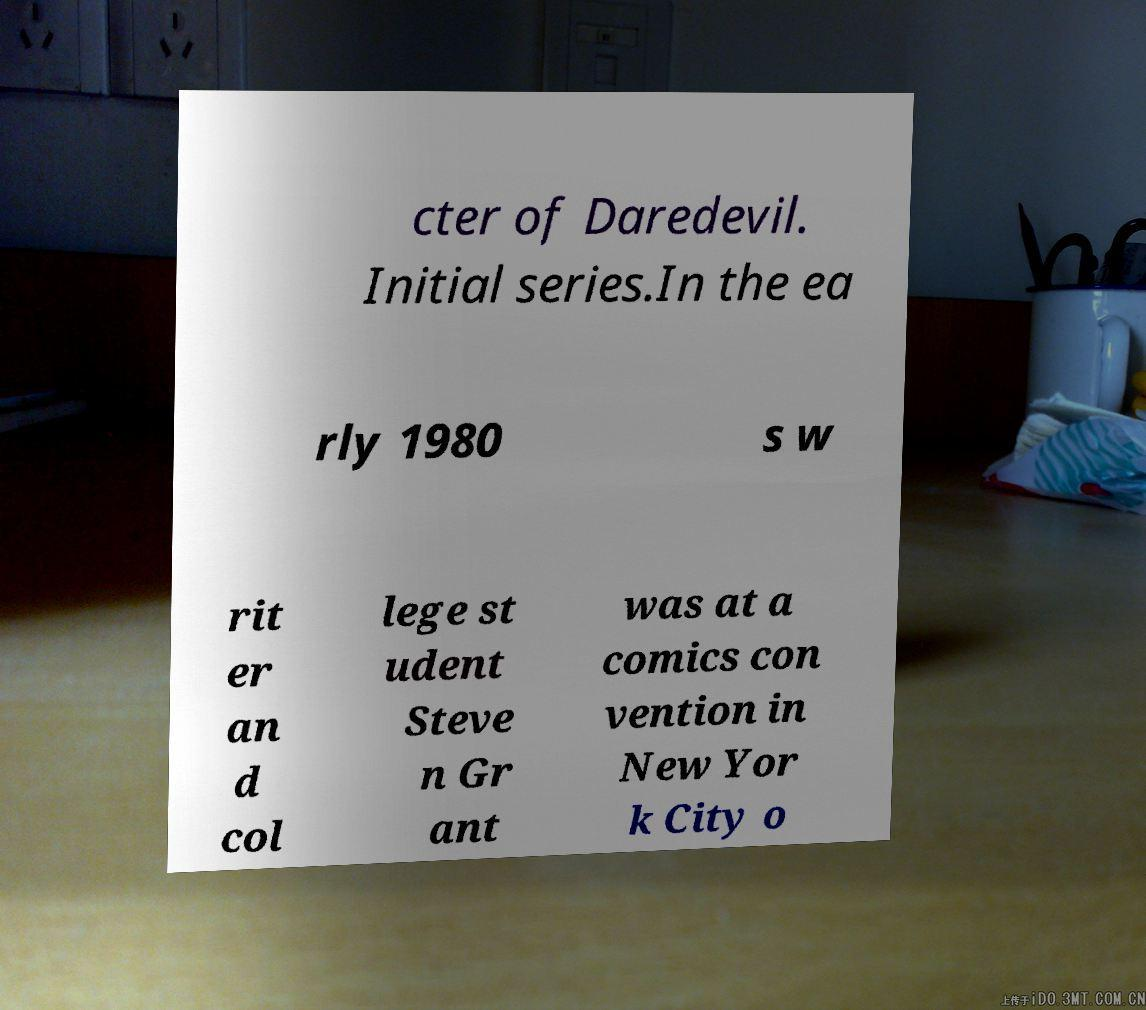Can you accurately transcribe the text from the provided image for me? cter of Daredevil. Initial series.In the ea rly 1980 s w rit er an d col lege st udent Steve n Gr ant was at a comics con vention in New Yor k City o 